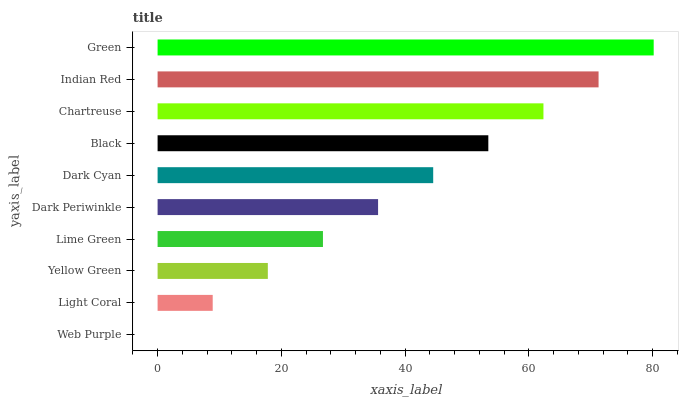Is Web Purple the minimum?
Answer yes or no. Yes. Is Green the maximum?
Answer yes or no. Yes. Is Light Coral the minimum?
Answer yes or no. No. Is Light Coral the maximum?
Answer yes or no. No. Is Light Coral greater than Web Purple?
Answer yes or no. Yes. Is Web Purple less than Light Coral?
Answer yes or no. Yes. Is Web Purple greater than Light Coral?
Answer yes or no. No. Is Light Coral less than Web Purple?
Answer yes or no. No. Is Dark Cyan the high median?
Answer yes or no. Yes. Is Dark Periwinkle the low median?
Answer yes or no. Yes. Is Green the high median?
Answer yes or no. No. Is Chartreuse the low median?
Answer yes or no. No. 